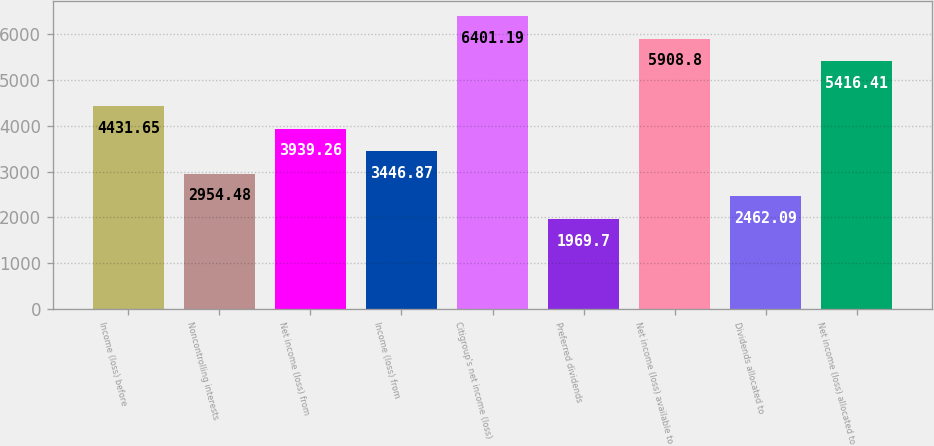Convert chart to OTSL. <chart><loc_0><loc_0><loc_500><loc_500><bar_chart><fcel>Income (loss) before<fcel>Noncontrolling interests<fcel>Net income (loss) from<fcel>Income (loss) from<fcel>Citigroup's net income (loss)<fcel>Preferred dividends<fcel>Net income (loss) available to<fcel>Dividends allocated to<fcel>Net income (loss) allocated to<nl><fcel>4431.65<fcel>2954.48<fcel>3939.26<fcel>3446.87<fcel>6401.19<fcel>1969.7<fcel>5908.8<fcel>2462.09<fcel>5416.41<nl></chart> 